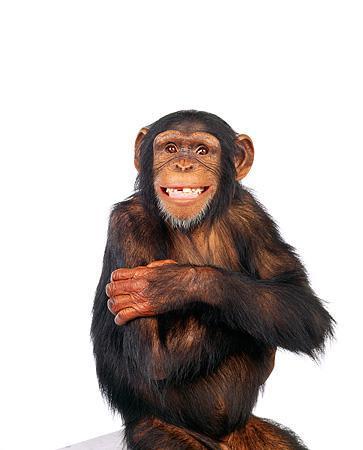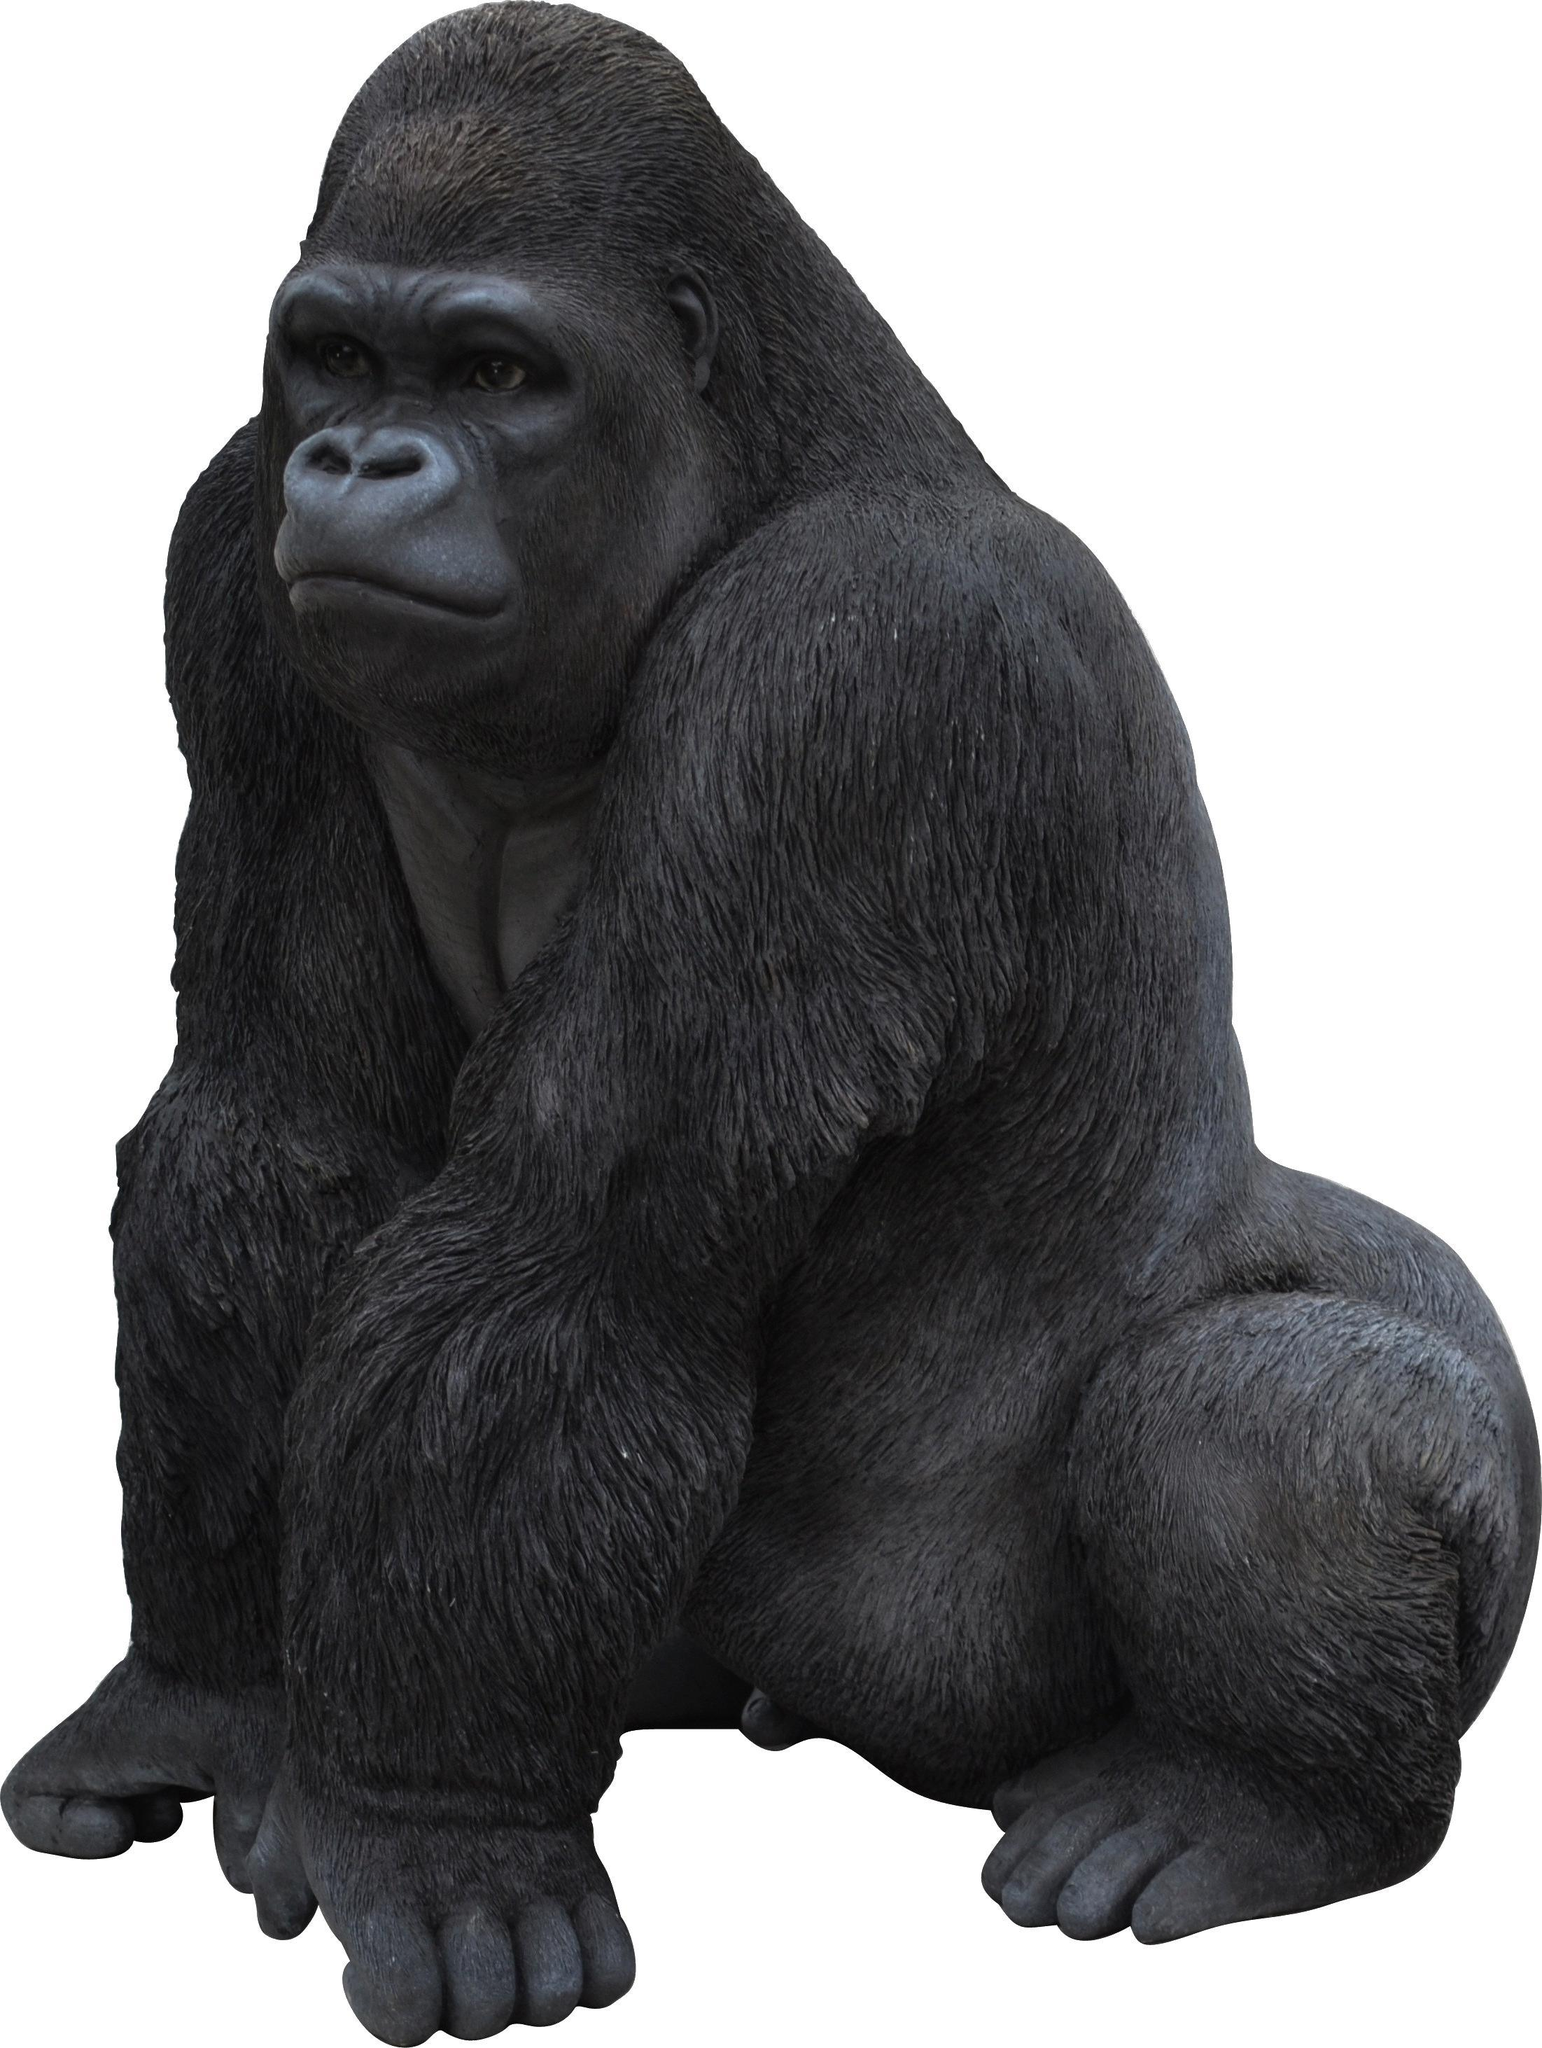The first image is the image on the left, the second image is the image on the right. For the images displayed, is the sentence "Each image shows exactly one chimpanzee, with at least one of its hands touching part of its body." factually correct? Answer yes or no. No. The first image is the image on the left, the second image is the image on the right. For the images shown, is this caption "A primate is being shown against a black background." true? Answer yes or no. No. 